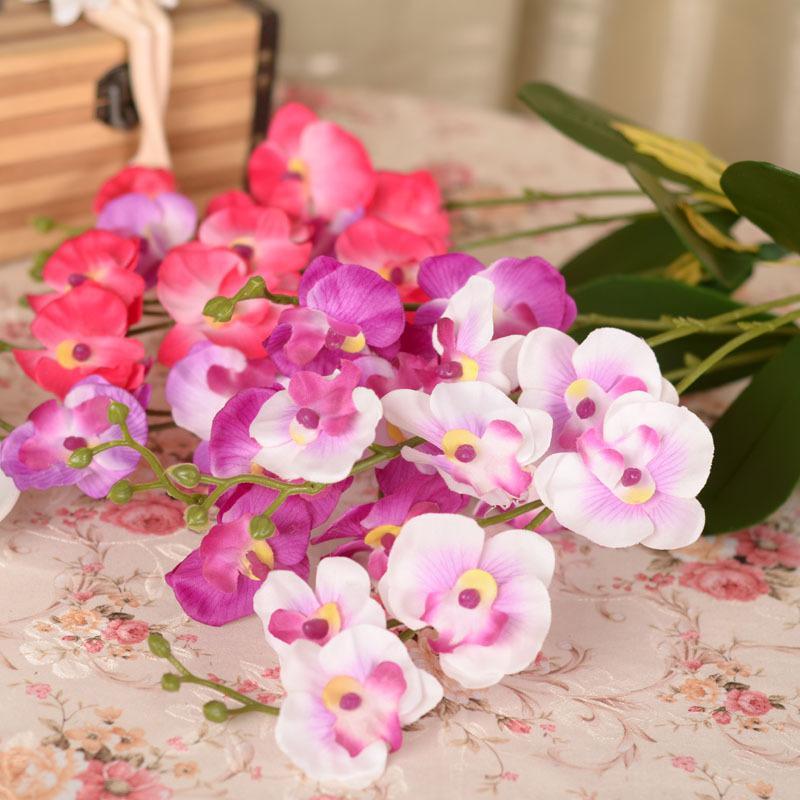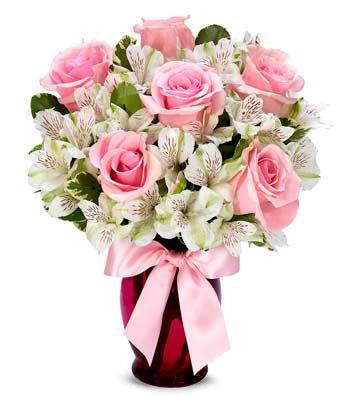The first image is the image on the left, the second image is the image on the right. Assess this claim about the two images: "There are stones at the bottom of one of the vases.". Correct or not? Answer yes or no. No. The first image is the image on the left, the second image is the image on the right. Examine the images to the left and right. Is the description "One image shows a transparent cylindrical vase with pebble-shaped objects inside, holding a bouquet of pink roses and ruffly white flowers." accurate? Answer yes or no. No. 